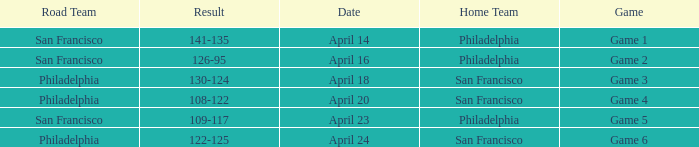Which games had Philadelphia as home team? Game 1, Game 2, Game 5. 